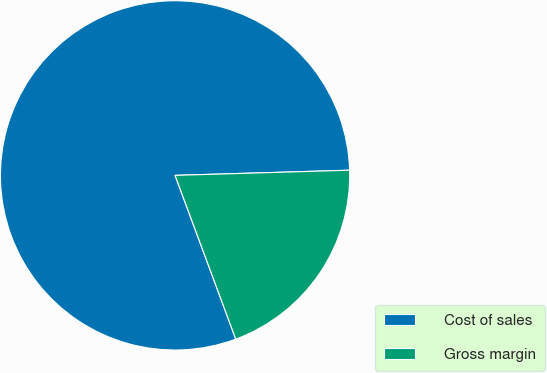Convert chart to OTSL. <chart><loc_0><loc_0><loc_500><loc_500><pie_chart><fcel>Cost of sales<fcel>Gross margin<nl><fcel>80.18%<fcel>19.82%<nl></chart> 